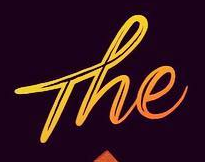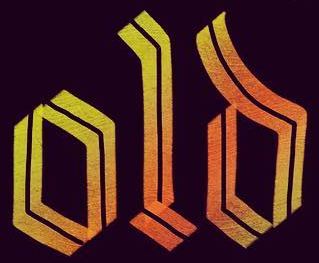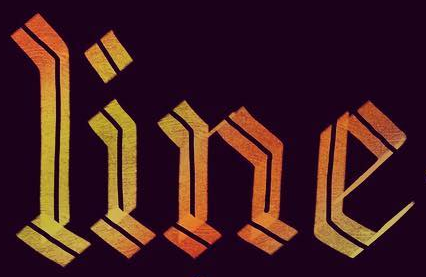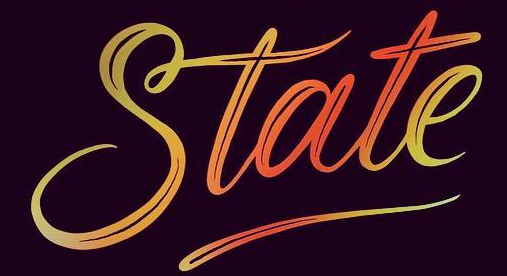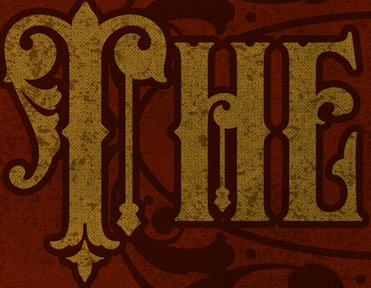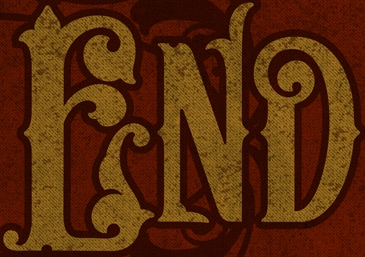Transcribe the words shown in these images in order, separated by a semicolon. The; old; line; State; THE; END 